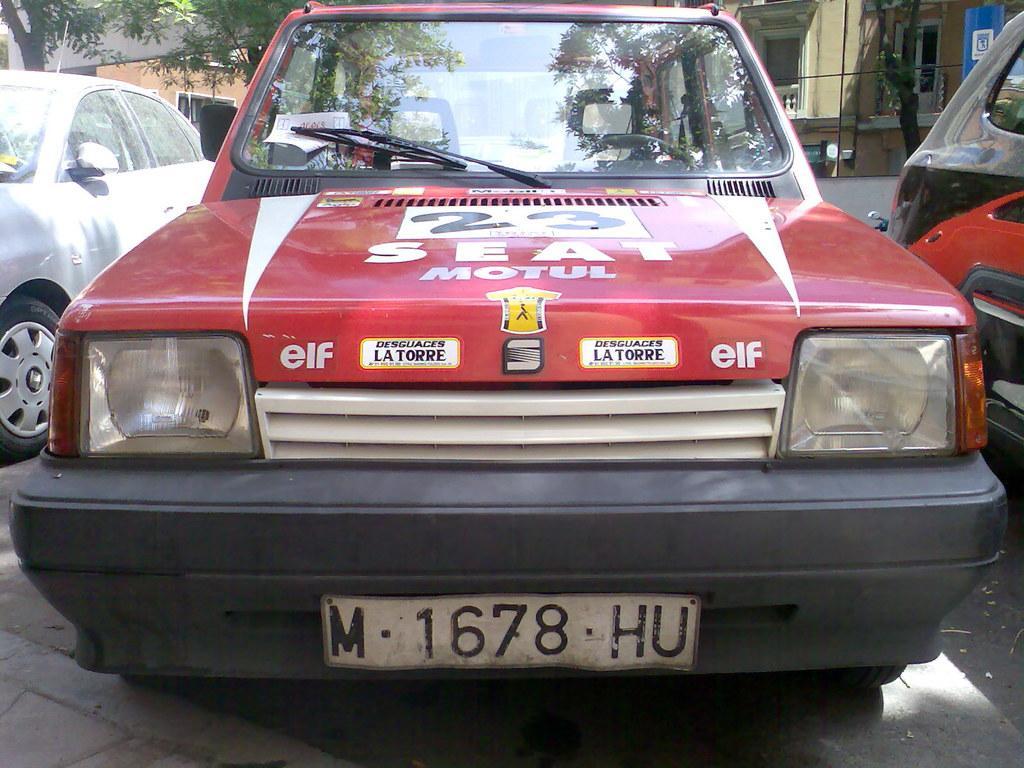How would you summarize this image in a sentence or two? In this picture we can see cars on the road and at the back of these cars we can see trees, signboard, buildings with windows and some objects. 